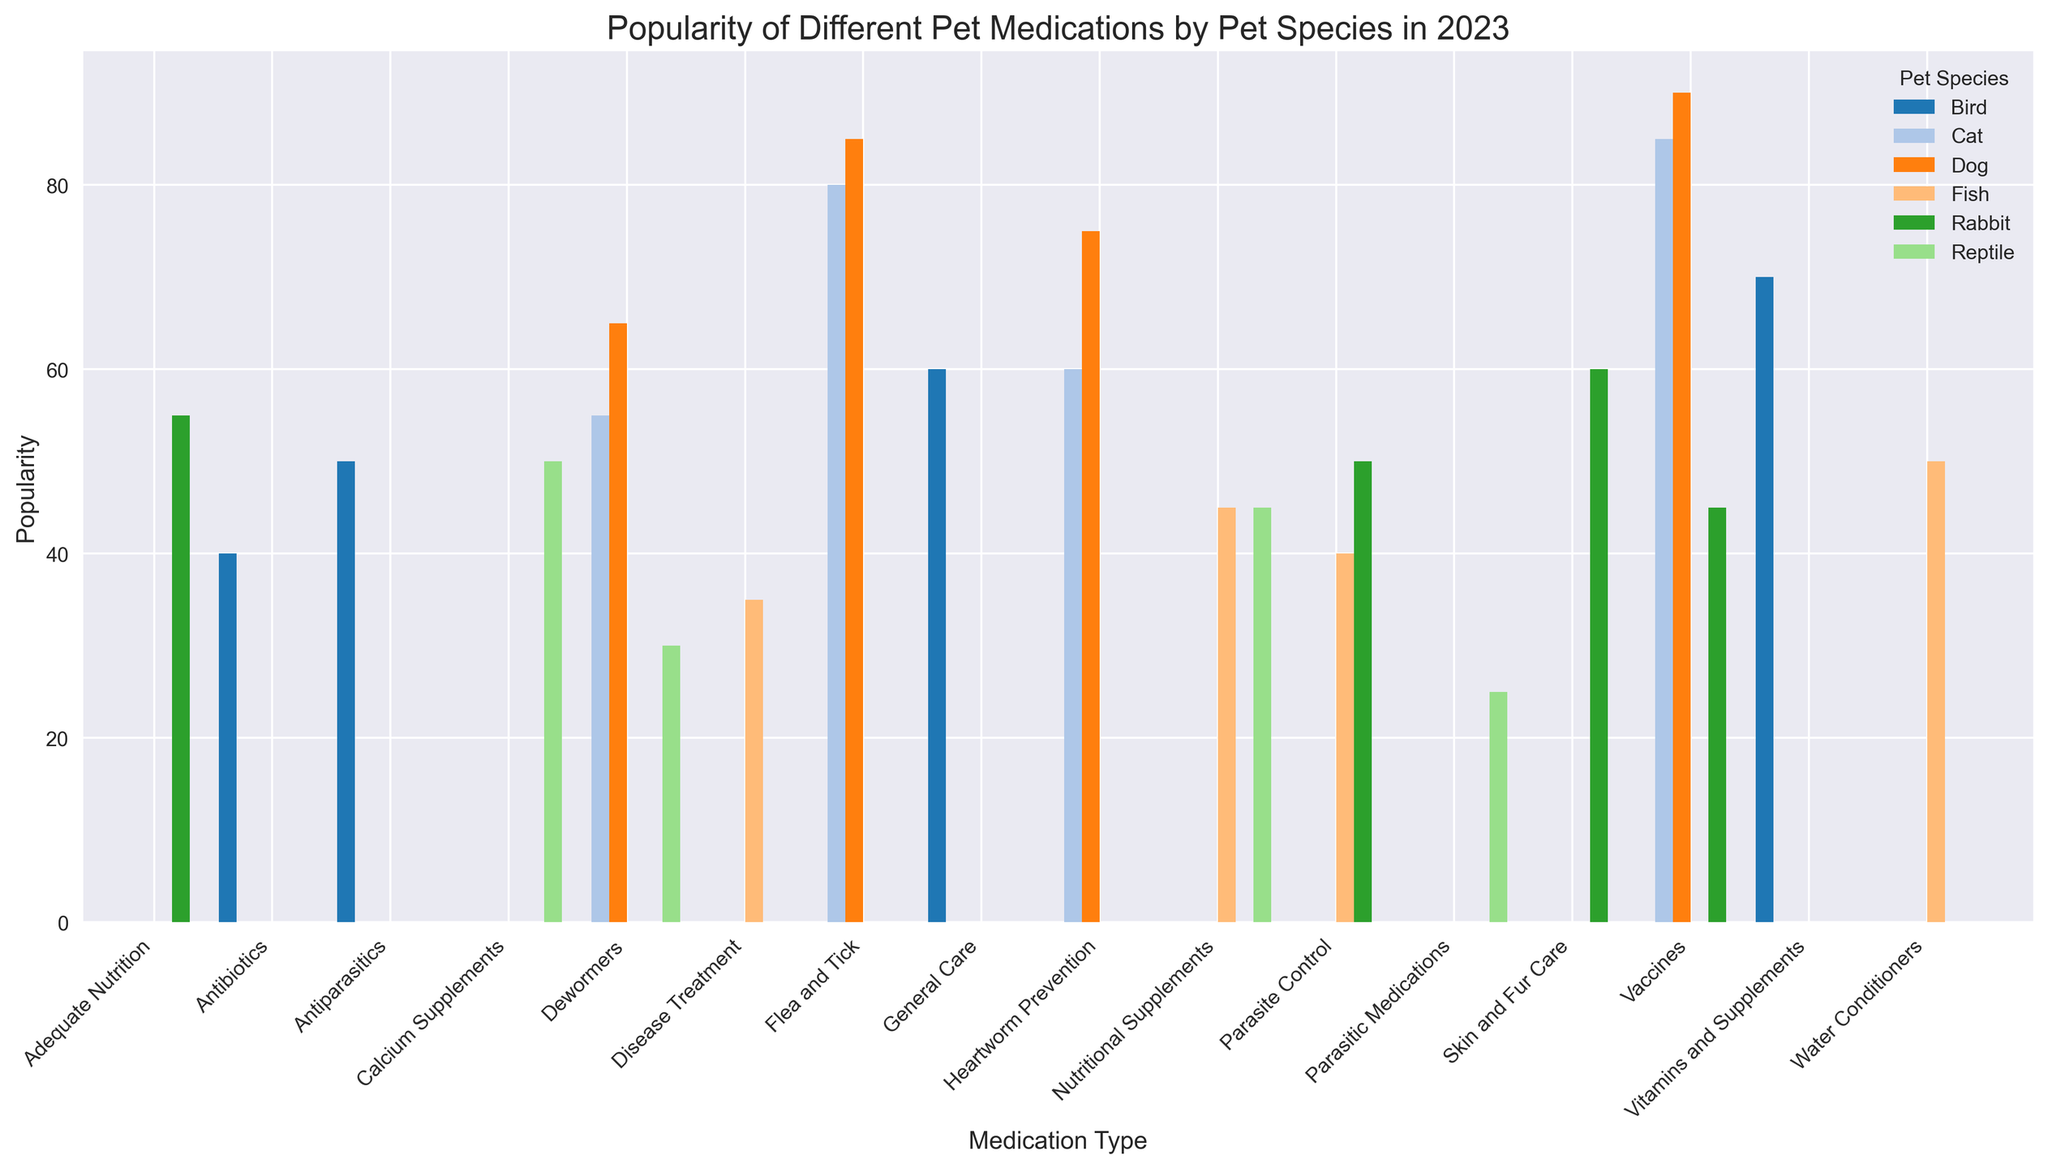What is the most popular medication type for dogs? The tallest bar in the 'Dog' group reveals the most popular medication type. This is "Vaccines" with a popularity of 90.
Answer: Vaccines Which pet species has the least popularity for Nutritional Supplements? Look at the bars corresponding to "Nutritional Supplements" for each pet species and identify the shortest bar. Fish have the lowest popularity in this category with 45.
Answer: Fish What is the difference in popularity between Flea and Tick medication for dogs and cats? Compare the heights of the bars for "Flea and Tick" medication under "Dog" and "Cat". The values are 85 and 80, respectively. The difference is 85 - 80 = 5.
Answer: 5 Which medication type has fairly balanced popularity across all pet species? Look for medication types where the heights of bars across all species are similar. "Vaccines" for dogs, cats, and rabbits show relatively balanced popularity.
Answer: Vaccines How much more popular are Antibiotics for birds than for fish? Check the bar heights for "Antibiotics" under "Bird" (40) and "Fish" (not listed). Since there are no Antibiotics listed for fish, the answer is simply the bird's value.
Answer: 40 Which pet species relies most on Heartworm Prevention medication? Among the bars for "Heartworm Prevention", find the tallest one. Dogs have a popularity of 75 while cats have 60; hence dogs rely most on this medication.
Answer: Dogs Is Dewormers medication more popular for reptiles or cats? Compare the bars for "Dewormers" in both the "Cat" and "Reptile" groups. Cats have 55, while reptiles have 30. Therefore, it's more popular for cats.
Answer: Cats Determine the average popularity of Vitamins and Supplements for birds and skin and fur care for rabbits. Add the popularity of "Vitamins and Supplements" for birds (70) and "Skin and Fur Care" for rabbits (60), then divide by 2. (70 + 60) / 2 = 65.
Answer: 65 How much higher is the popularity of General Care medication for birds compared to Disease Treatment for fish? Check the bar heights for "General Care" (60) and "Disease Treatment" (35). The difference is 60 - 35 = 25.
Answer: 25 What is the total popularity of different parasite control medications for all species? Sum the popularity of "Flea and Tick" for dogs (85), cats (80), "Antiparasitics" for birds (50), "Parasite Control" for fish (40) and rabbits (50), and "Parasitic Medications" for reptiles (25). 85 + 80 + 50 + 40 + 50 + 25 = 330.
Answer: 330 